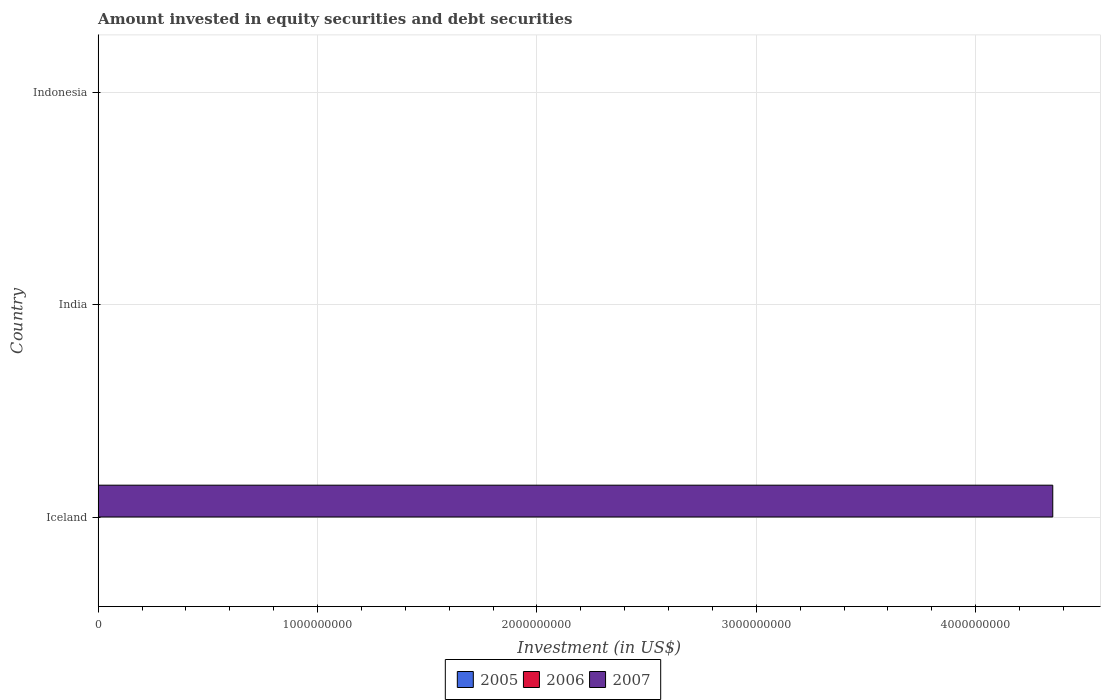How many different coloured bars are there?
Your answer should be compact. 1. Are the number of bars per tick equal to the number of legend labels?
Make the answer very short. No. In how many cases, is the number of bars for a given country not equal to the number of legend labels?
Offer a terse response. 3. Across all countries, what is the maximum amount invested in equity securities and debt securities in 2007?
Your answer should be very brief. 4.35e+09. Across all countries, what is the minimum amount invested in equity securities and debt securities in 2005?
Give a very brief answer. 0. What is the total amount invested in equity securities and debt securities in 2007 in the graph?
Provide a short and direct response. 4.35e+09. What is the average amount invested in equity securities and debt securities in 2007 per country?
Provide a short and direct response. 1.45e+09. In how many countries, is the amount invested in equity securities and debt securities in 2005 greater than 3200000000 US$?
Offer a terse response. 0. In how many countries, is the amount invested in equity securities and debt securities in 2006 greater than the average amount invested in equity securities and debt securities in 2006 taken over all countries?
Give a very brief answer. 0. Is it the case that in every country, the sum of the amount invested in equity securities and debt securities in 2005 and amount invested in equity securities and debt securities in 2007 is greater than the amount invested in equity securities and debt securities in 2006?
Your answer should be compact. No. Are the values on the major ticks of X-axis written in scientific E-notation?
Keep it short and to the point. No. Where does the legend appear in the graph?
Your answer should be very brief. Bottom center. How many legend labels are there?
Make the answer very short. 3. How are the legend labels stacked?
Give a very brief answer. Horizontal. What is the title of the graph?
Provide a succinct answer. Amount invested in equity securities and debt securities. Does "1994" appear as one of the legend labels in the graph?
Provide a succinct answer. No. What is the label or title of the X-axis?
Give a very brief answer. Investment (in US$). What is the label or title of the Y-axis?
Keep it short and to the point. Country. What is the Investment (in US$) in 2005 in Iceland?
Offer a very short reply. 0. What is the Investment (in US$) in 2006 in Iceland?
Offer a terse response. 0. What is the Investment (in US$) of 2007 in Iceland?
Provide a short and direct response. 4.35e+09. What is the Investment (in US$) of 2007 in India?
Your answer should be compact. 0. What is the Investment (in US$) in 2006 in Indonesia?
Offer a terse response. 0. What is the Investment (in US$) of 2007 in Indonesia?
Offer a very short reply. 0. Across all countries, what is the maximum Investment (in US$) in 2007?
Keep it short and to the point. 4.35e+09. What is the total Investment (in US$) of 2006 in the graph?
Provide a succinct answer. 0. What is the total Investment (in US$) of 2007 in the graph?
Offer a terse response. 4.35e+09. What is the average Investment (in US$) in 2006 per country?
Your response must be concise. 0. What is the average Investment (in US$) of 2007 per country?
Offer a terse response. 1.45e+09. What is the difference between the highest and the lowest Investment (in US$) of 2007?
Provide a succinct answer. 4.35e+09. 